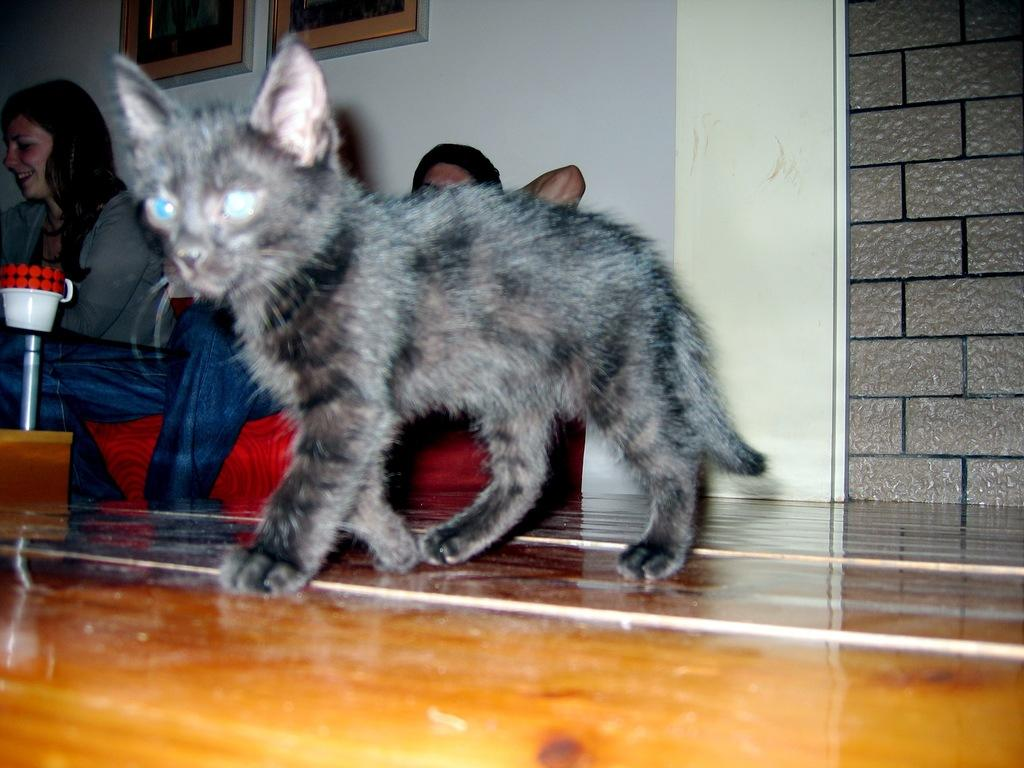What type of animal is in the image? There is a black cat in the image. What is the cat doing in the image? The cat is walking on the floor. Who else is present in the image? There is a woman in the image. What is the woman doing in the image? The woman is sitting on a sofa. Where is the sofa located in the image? The sofa is on the left side of the image. What letters are being exchanged between the cat and the woman in the image? There are no letters being exchanged in the image; it simply shows a cat walking on the floor and a woman sitting on a sofa. 